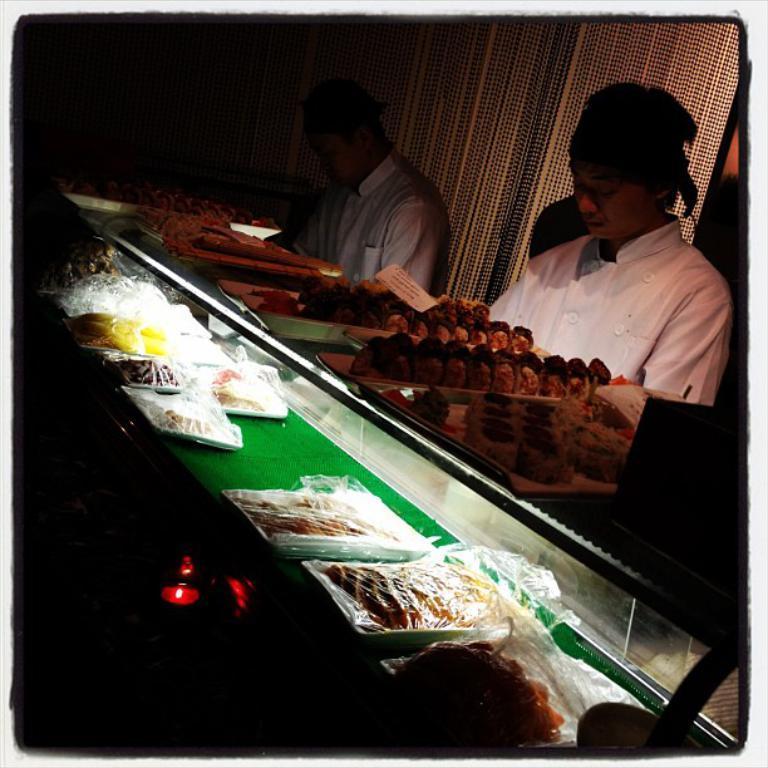How would you summarize this image in a sentence or two? In this image I can see two persons, the person at right is wearing white color shirt. In front I can see few food items on the glass surface. 